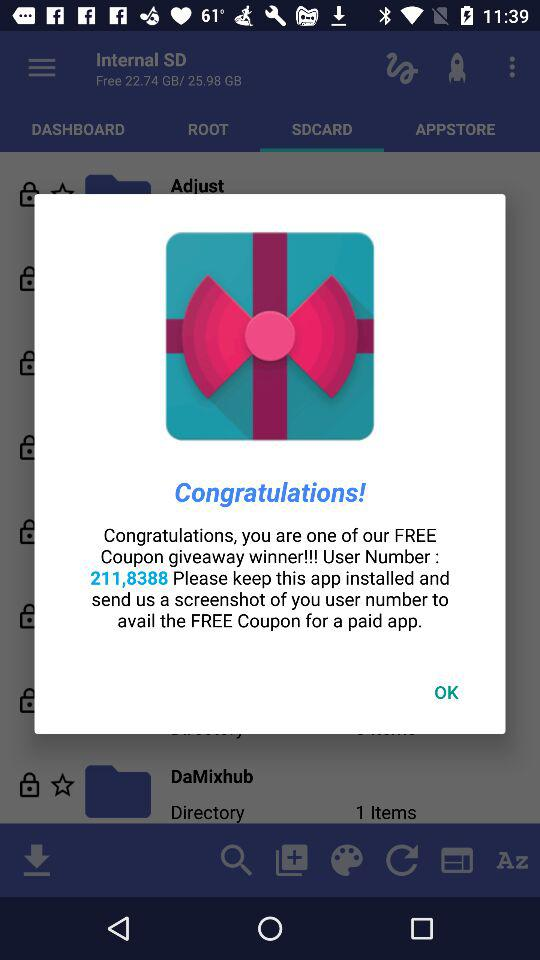What is the size of the internal secure digital card? The size of the internal secure digital card is 25.98 GB. 